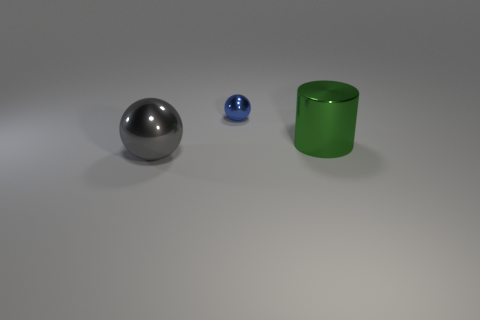Is there a big green cylinder made of the same material as the tiny thing?
Provide a short and direct response. Yes. There is a sphere that is behind the metal object in front of the green shiny cylinder that is to the right of the big metal sphere; what color is it?
Keep it short and to the point. Blue. What number of gray objects are tiny metal balls or large metal spheres?
Your answer should be very brief. 1. What number of other large green things have the same shape as the green object?
Provide a short and direct response. 0. There is another object that is the same size as the green object; what is its shape?
Ensure brevity in your answer.  Sphere. There is a small thing; are there any big objects to the left of it?
Give a very brief answer. Yes. There is a large thing right of the large gray ball; are there any big objects that are in front of it?
Provide a short and direct response. Yes. Are there fewer big green metal things to the right of the big cylinder than big green cylinders on the right side of the blue object?
Keep it short and to the point. Yes. Is there any other thing that is the same size as the blue shiny ball?
Ensure brevity in your answer.  No. What is the shape of the green thing?
Ensure brevity in your answer.  Cylinder. 